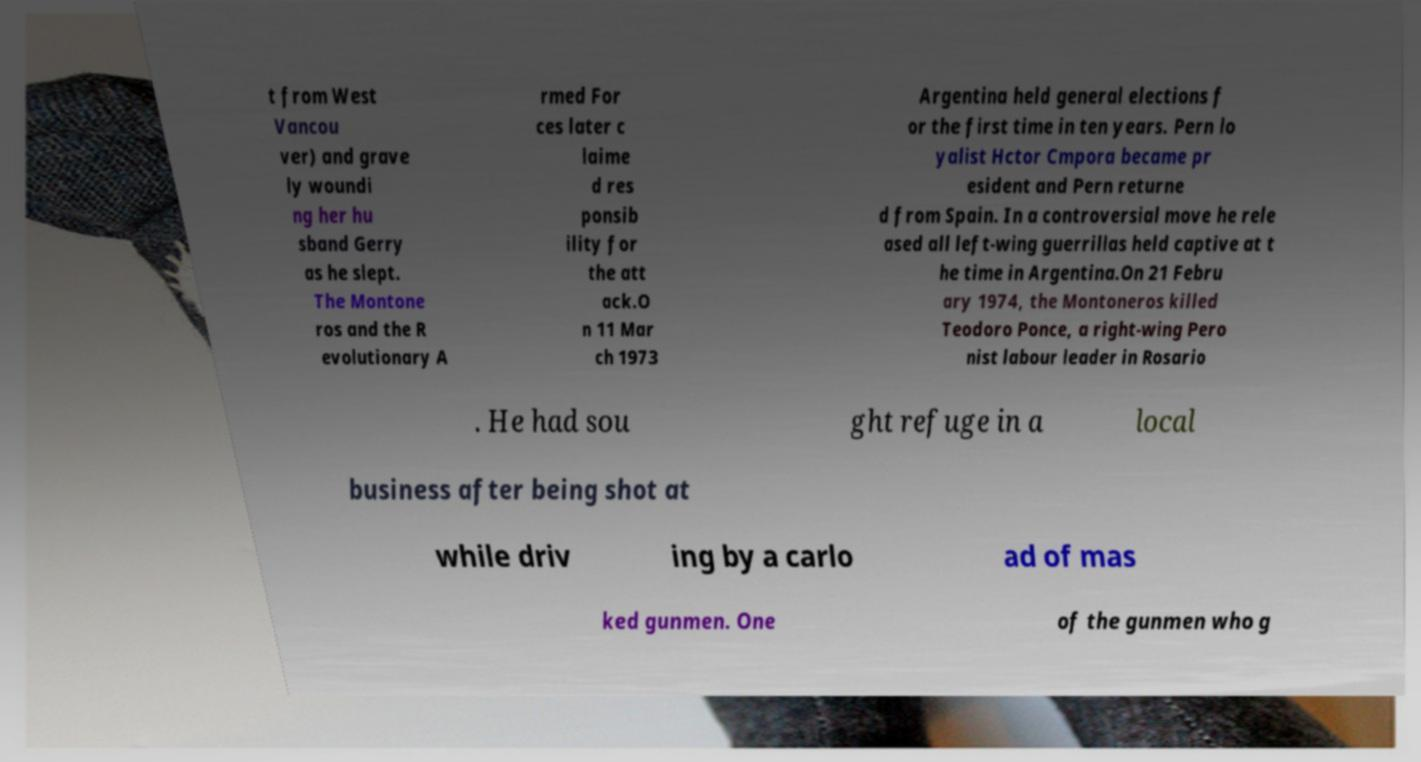For documentation purposes, I need the text within this image transcribed. Could you provide that? t from West Vancou ver) and grave ly woundi ng her hu sband Gerry as he slept. The Montone ros and the R evolutionary A rmed For ces later c laime d res ponsib ility for the att ack.O n 11 Mar ch 1973 Argentina held general elections f or the first time in ten years. Pern lo yalist Hctor Cmpora became pr esident and Pern returne d from Spain. In a controversial move he rele ased all left-wing guerrillas held captive at t he time in Argentina.On 21 Febru ary 1974, the Montoneros killed Teodoro Ponce, a right-wing Pero nist labour leader in Rosario . He had sou ght refuge in a local business after being shot at while driv ing by a carlo ad of mas ked gunmen. One of the gunmen who g 